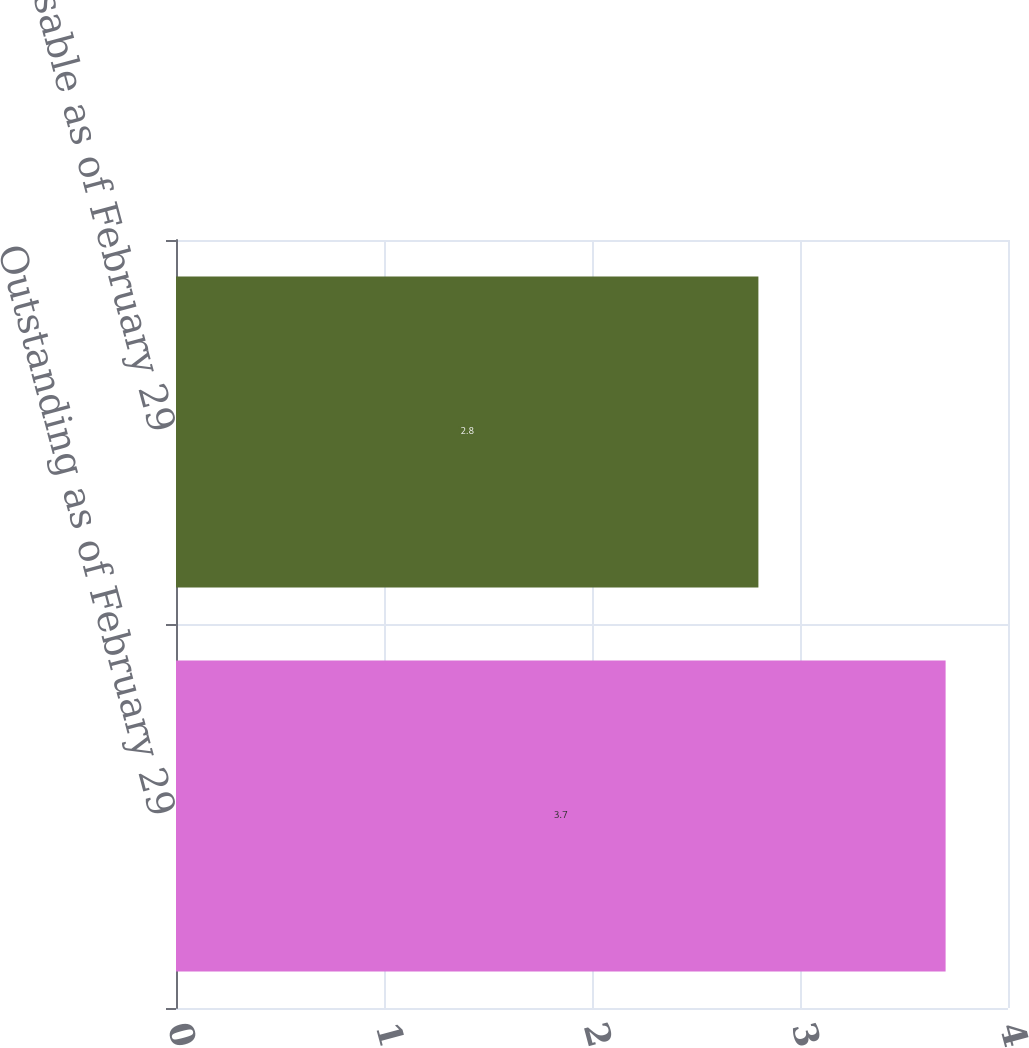<chart> <loc_0><loc_0><loc_500><loc_500><bar_chart><fcel>Outstanding as of February 29<fcel>Exercisable as of February 29<nl><fcel>3.7<fcel>2.8<nl></chart> 